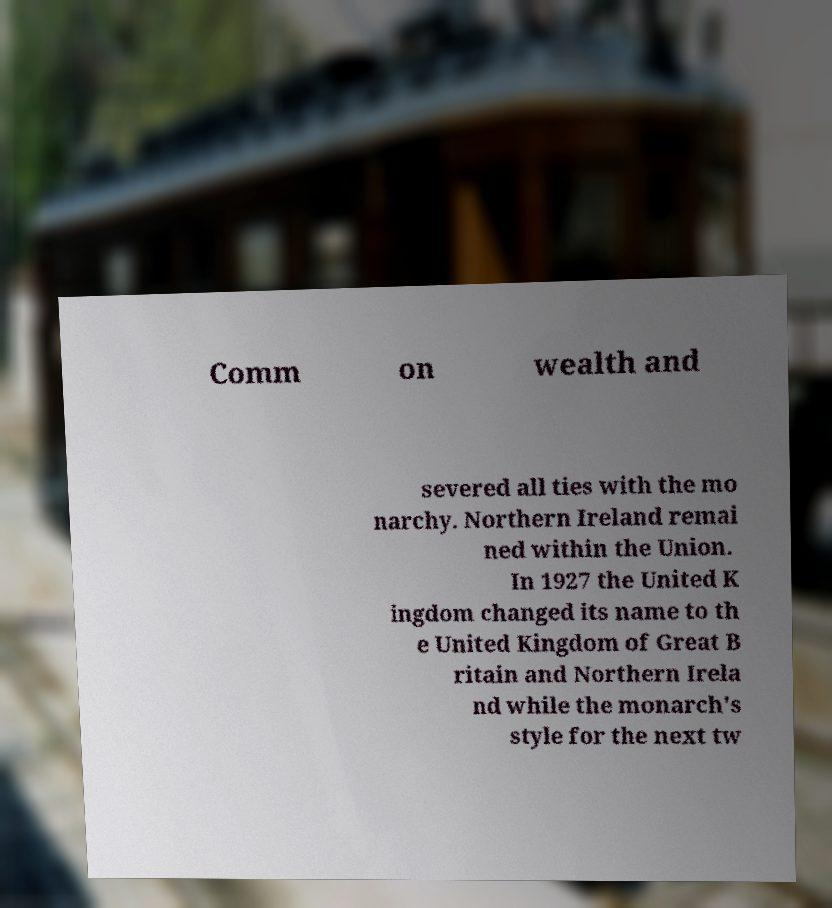Please identify and transcribe the text found in this image. Comm on wealth and severed all ties with the mo narchy. Northern Ireland remai ned within the Union. In 1927 the United K ingdom changed its name to th e United Kingdom of Great B ritain and Northern Irela nd while the monarch's style for the next tw 